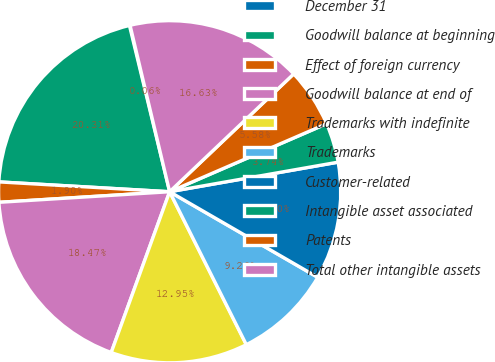Convert chart. <chart><loc_0><loc_0><loc_500><loc_500><pie_chart><fcel>December 31<fcel>Goodwill balance at beginning<fcel>Effect of foreign currency<fcel>Goodwill balance at end of<fcel>Trademarks with indefinite<fcel>Trademarks<fcel>Customer-related<fcel>Intangible asset associated<fcel>Patents<fcel>Total other intangible assets<nl><fcel>0.06%<fcel>20.3%<fcel>1.9%<fcel>18.46%<fcel>12.94%<fcel>9.26%<fcel>11.1%<fcel>3.74%<fcel>5.58%<fcel>16.62%<nl></chart> 